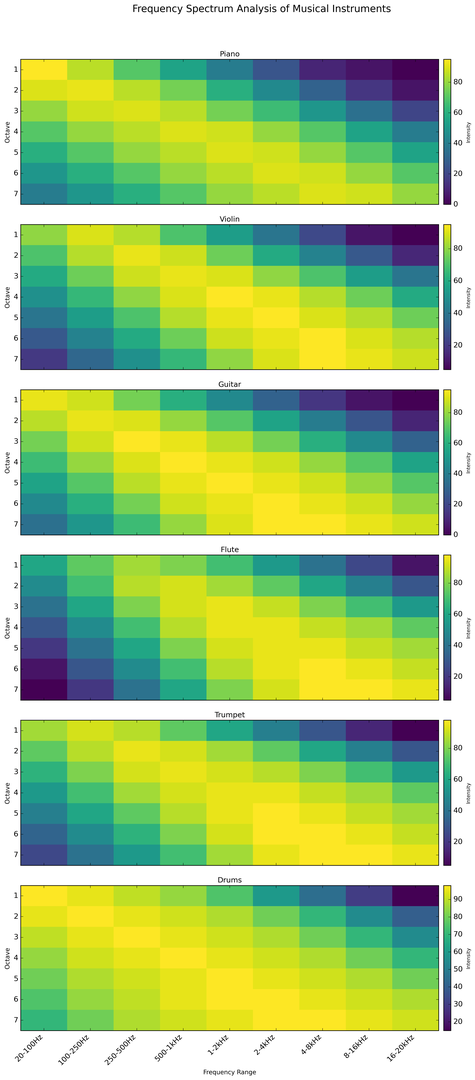What instrument has the highest average intensity across all octaves? Calculate the average intensity for each instrument across all frequency ranges and octaves. For example, for the Piano, sum all the intensity values (1870) and divide by the total number of data points (63). Repeat this for all instruments and compare their averages.
Answer: Drums Which instrument shows a clear increase in intensity as the frequency range increases within a single octave? Examine the heatmap for each instrument and identify any that show a color gradient moving from dark (low intensity) to bright (high intensity) within individual rows representing single octaves.
Answer: Flute In which octave does the Piano have its peak intensity for the 2-4kHz range? Look at the 'Piano' row in the heatmap and identify the octave where the 2-4kHz frequency range has its highest intensity value.
Answer: Octave 5 Compare the intensity distribution of the 20-100Hz frequency range across all octaves for the Violin and the Trumpet. Which one has a higher average intensity? For both Violin and Trumpet, sum up the intensity values in the 20-100Hz column across all octaves and then divide by the number of octaves (7) to find the average intensity for each instrument. Compare these averages.
Answer: Violin For the Guitar, which frequency range has the most uniform intensity distribution across all octaves? Look at the rows corresponding to the Guitar on the heatmap and identify which frequency range has the least color variation, indicating a uniform distribution.
Answer: 1-2kHz Which frequency range has the lowest intensity for the Flute in octave 5? Examine the row corresponding to Octave 5 of the Flute and identify the frequency range with the darkest color or lowest intensity value.
Answer: 20-100Hz Is the intensity for the Drums in the 500-1kHz range ever greater than 95? If yes, in which octave? Check all the octaves for Drums in the 500-1kHz column to see if any value exceeds 95. Identify the corresponding octave if true.
Answer: Yes, Octaves 4, 5, 6, 7 What is the difference in intensity for the 250-500Hz range between Flute in Octave 2 and Trumpet in Octave 2? Look at the intensity values for Flute (88) and Trumpet (95) in the 250-500Hz range and Octave 2. Subtract the intensity of the Flute from that of the Trumpet.
Answer: 7 Which instrument has the highest intensity in the 16-20kHz range overall? Identify the highest value in the 16-20kHz column for each instrument and compare these to find the maximum.
Answer: Flute Does the Violin show a higher intensity in the 1-2kHz range at lower or higher octaves? Examine the intensity values for Violin in the 1-2kHz range and compare values at lower octaves (1-3) vs. higher octaves (4-7).
Answer: Higher Octaves 